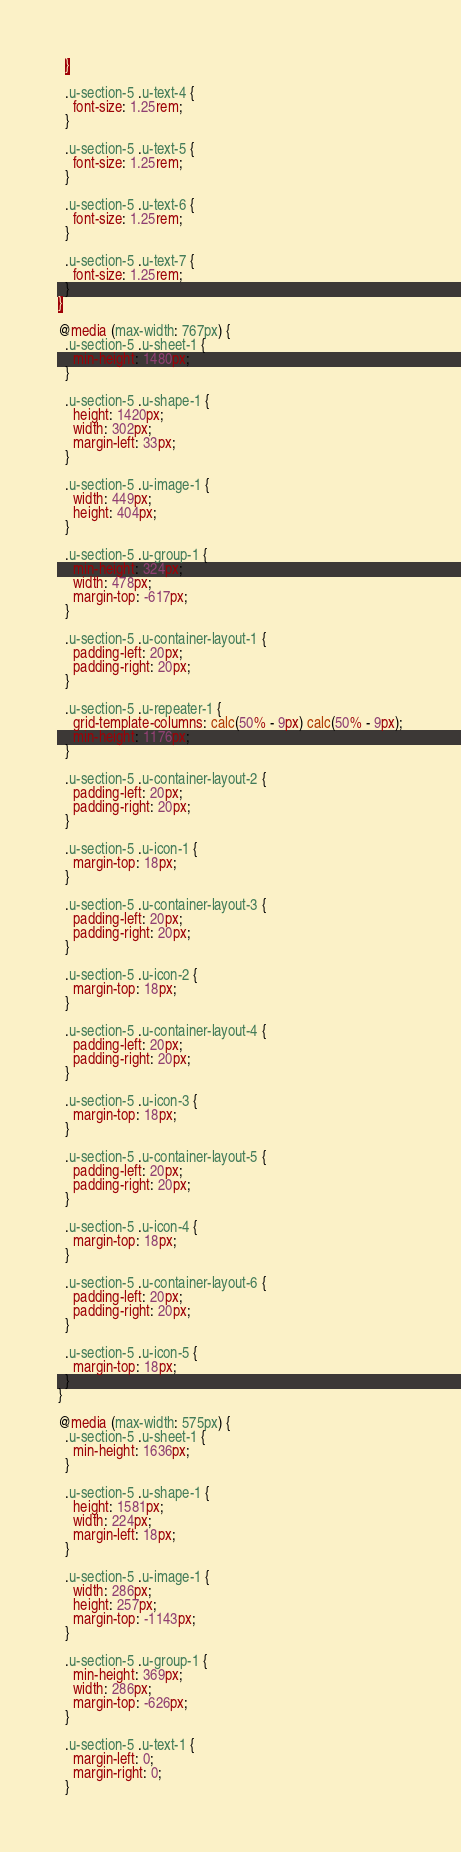<code> <loc_0><loc_0><loc_500><loc_500><_CSS_>  }

  .u-section-5 .u-text-4 {
    font-size: 1.25rem;
  }

  .u-section-5 .u-text-5 {
    font-size: 1.25rem;
  }

  .u-section-5 .u-text-6 {
    font-size: 1.25rem;
  }

  .u-section-5 .u-text-7 {
    font-size: 1.25rem;
  }
}

@media (max-width: 767px) {
  .u-section-5 .u-sheet-1 {
    min-height: 1480px;
  }

  .u-section-5 .u-shape-1 {
    height: 1420px;
    width: 302px;
    margin-left: 33px;
  }

  .u-section-5 .u-image-1 {
    width: 449px;
    height: 404px;
  }

  .u-section-5 .u-group-1 {
    min-height: 324px;
    width: 478px;
    margin-top: -617px;
  }

  .u-section-5 .u-container-layout-1 {
    padding-left: 20px;
    padding-right: 20px;
  }

  .u-section-5 .u-repeater-1 {
    grid-template-columns: calc(50% - 9px) calc(50% - 9px);
    min-height: 1176px;
  }

  .u-section-5 .u-container-layout-2 {
    padding-left: 20px;
    padding-right: 20px;
  }

  .u-section-5 .u-icon-1 {
    margin-top: 18px;
  }

  .u-section-5 .u-container-layout-3 {
    padding-left: 20px;
    padding-right: 20px;
  }

  .u-section-5 .u-icon-2 {
    margin-top: 18px;
  }

  .u-section-5 .u-container-layout-4 {
    padding-left: 20px;
    padding-right: 20px;
  }

  .u-section-5 .u-icon-3 {
    margin-top: 18px;
  }

  .u-section-5 .u-container-layout-5 {
    padding-left: 20px;
    padding-right: 20px;
  }

  .u-section-5 .u-icon-4 {
    margin-top: 18px;
  }

  .u-section-5 .u-container-layout-6 {
    padding-left: 20px;
    padding-right: 20px;
  }

  .u-section-5 .u-icon-5 {
    margin-top: 18px;
  }
}

@media (max-width: 575px) {
  .u-section-5 .u-sheet-1 {
    min-height: 1636px;
  }

  .u-section-5 .u-shape-1 {
    height: 1581px;
    width: 224px;
    margin-left: 18px;
  }

  .u-section-5 .u-image-1 {
    width: 286px;
    height: 257px;
    margin-top: -1143px;
  }

  .u-section-5 .u-group-1 {
    min-height: 369px;
    width: 286px;
    margin-top: -626px;
  }

  .u-section-5 .u-text-1 {
    margin-left: 0;
    margin-right: 0;
  }
</code> 